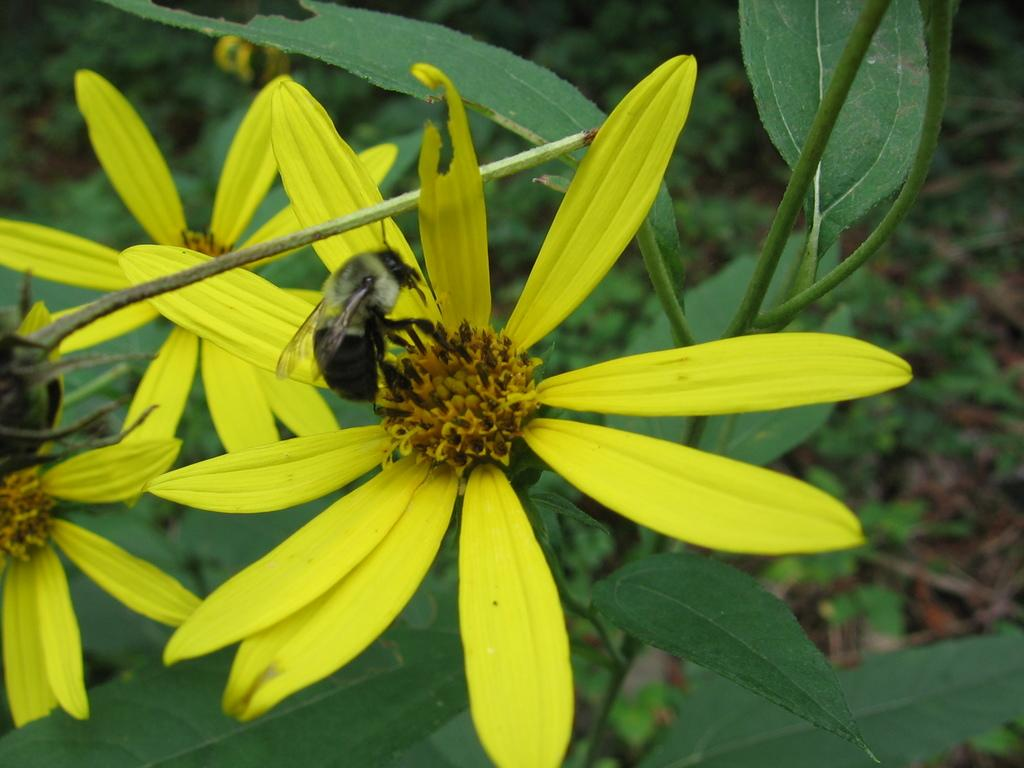What is present on the flower in the image? There is an insect on the flower in the image. What color is the flower that the insect is on? The flower is yellow. What can be seen in the background of the image? There are plants with green leaves in the background of the image. What type of air is being used by the insect to fly in the image? The image does not provide information about the type of air being used by the insect to fly. Is there an umbrella present in the image? No, there is no umbrella present in the image. 